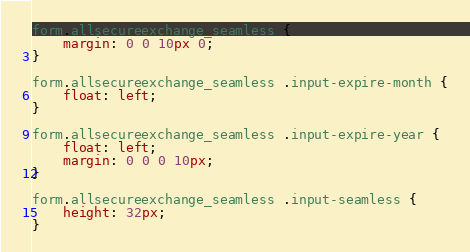Convert code to text. <code><loc_0><loc_0><loc_500><loc_500><_CSS_>
form.allsecureexchange_seamless {
    margin: 0 0 10px 0;
}

form.allsecureexchange_seamless .input-expire-month {
    float: left;
}

form.allsecureexchange_seamless .input-expire-year {
    float: left;
    margin: 0 0 0 10px;
}

form.allsecureexchange_seamless .input-seamless {
    height: 32px;
}
</code> 